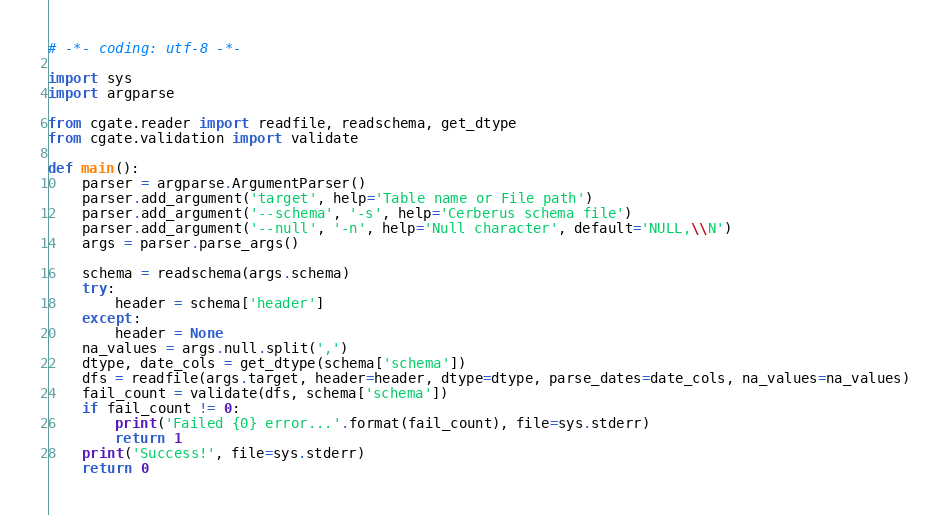<code> <loc_0><loc_0><loc_500><loc_500><_Python_># -*- coding: utf-8 -*-

import sys
import argparse

from cgate.reader import readfile, readschema, get_dtype
from cgate.validation import validate

def main():
    parser = argparse.ArgumentParser()
    parser.add_argument('target', help='Table name or File path')
    parser.add_argument('--schema', '-s', help='Cerberus schema file')
    parser.add_argument('--null', '-n', help='Null character', default='NULL,\\N')
    args = parser.parse_args()

    schema = readschema(args.schema)
    try:
        header = schema['header']
    except:
        header = None
    na_values = args.null.split(',')
    dtype, date_cols = get_dtype(schema['schema'])
    dfs = readfile(args.target, header=header, dtype=dtype, parse_dates=date_cols, na_values=na_values)
    fail_count = validate(dfs, schema['schema'])
    if fail_count != 0:
        print('Failed {0} error...'.format(fail_count), file=sys.stderr)
        return 1
    print('Success!', file=sys.stderr)
    return 0
</code> 